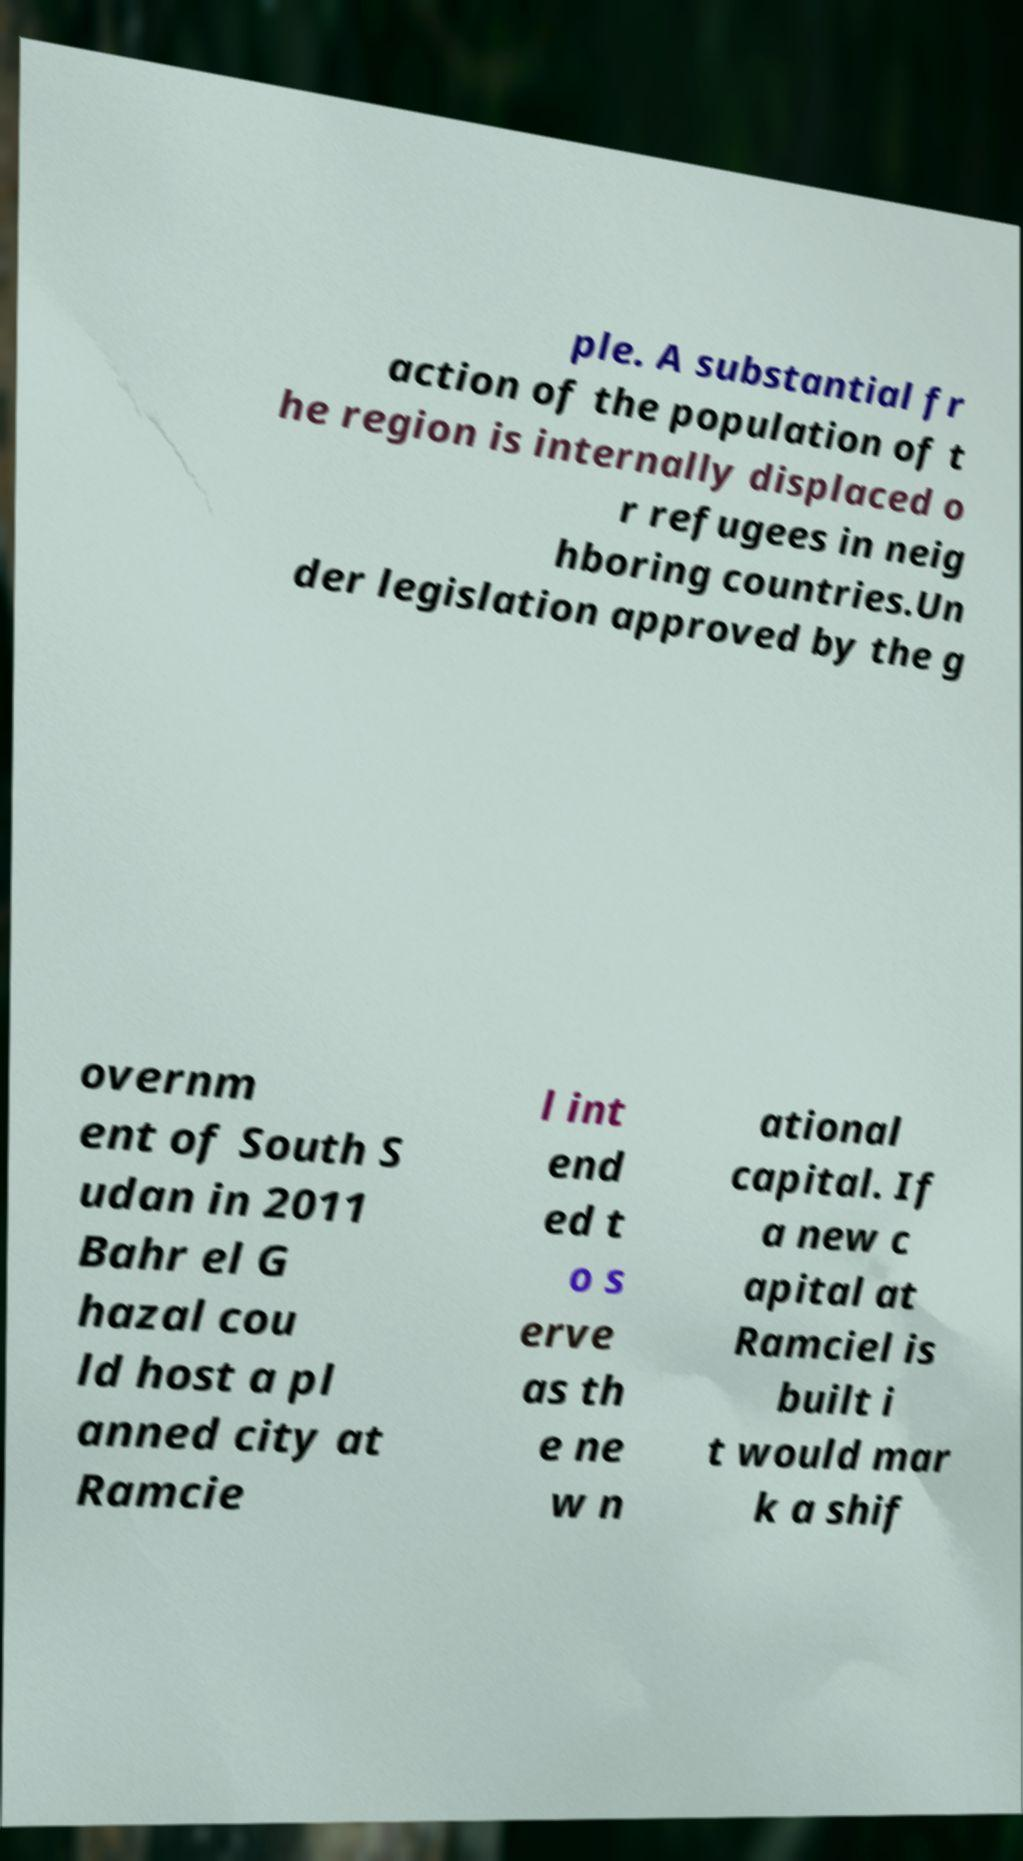What messages or text are displayed in this image? I need them in a readable, typed format. ple. A substantial fr action of the population of t he region is internally displaced o r refugees in neig hboring countries.Un der legislation approved by the g overnm ent of South S udan in 2011 Bahr el G hazal cou ld host a pl anned city at Ramcie l int end ed t o s erve as th e ne w n ational capital. If a new c apital at Ramciel is built i t would mar k a shif 